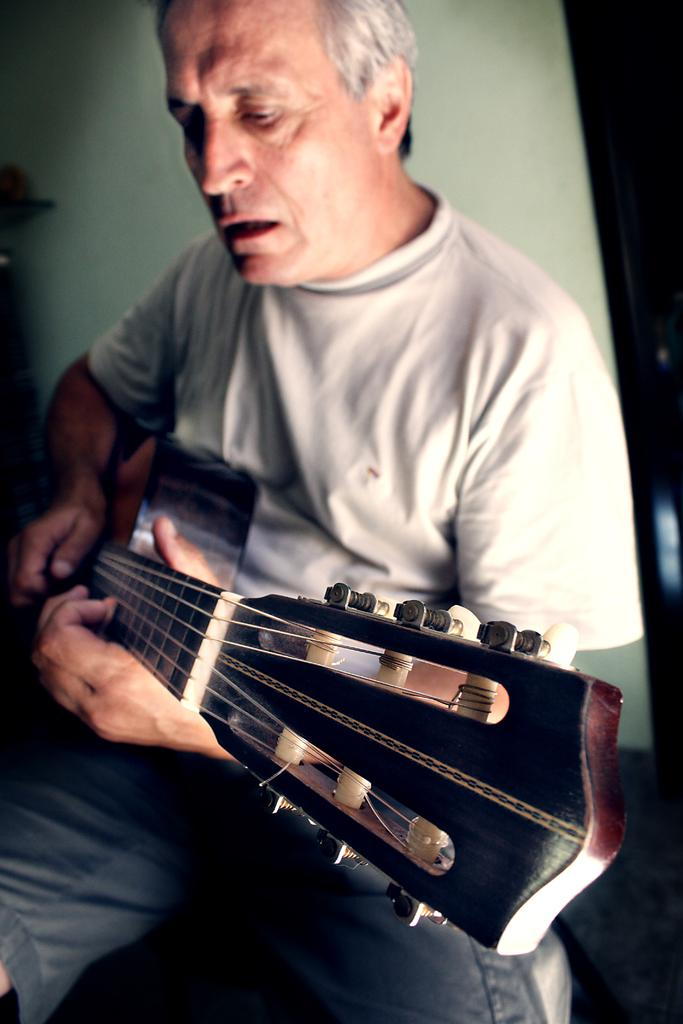What is the man in the image doing? The man is playing a guitar. How is the man positioned in the image? The man is seated. What is the man wearing on his upper body? The man is wearing a white t-shirt. What is the man wearing on his lower body? The man is wearing shorts. What type of yarn is the man using to play the guitar in the image? There is no yarn present in the image, and the man is playing a guitar, not a yarn instrument. Can you see any mist in the image? There is no mention of mist in the provided facts, and therefore it cannot be determined if mist is present in the image. 